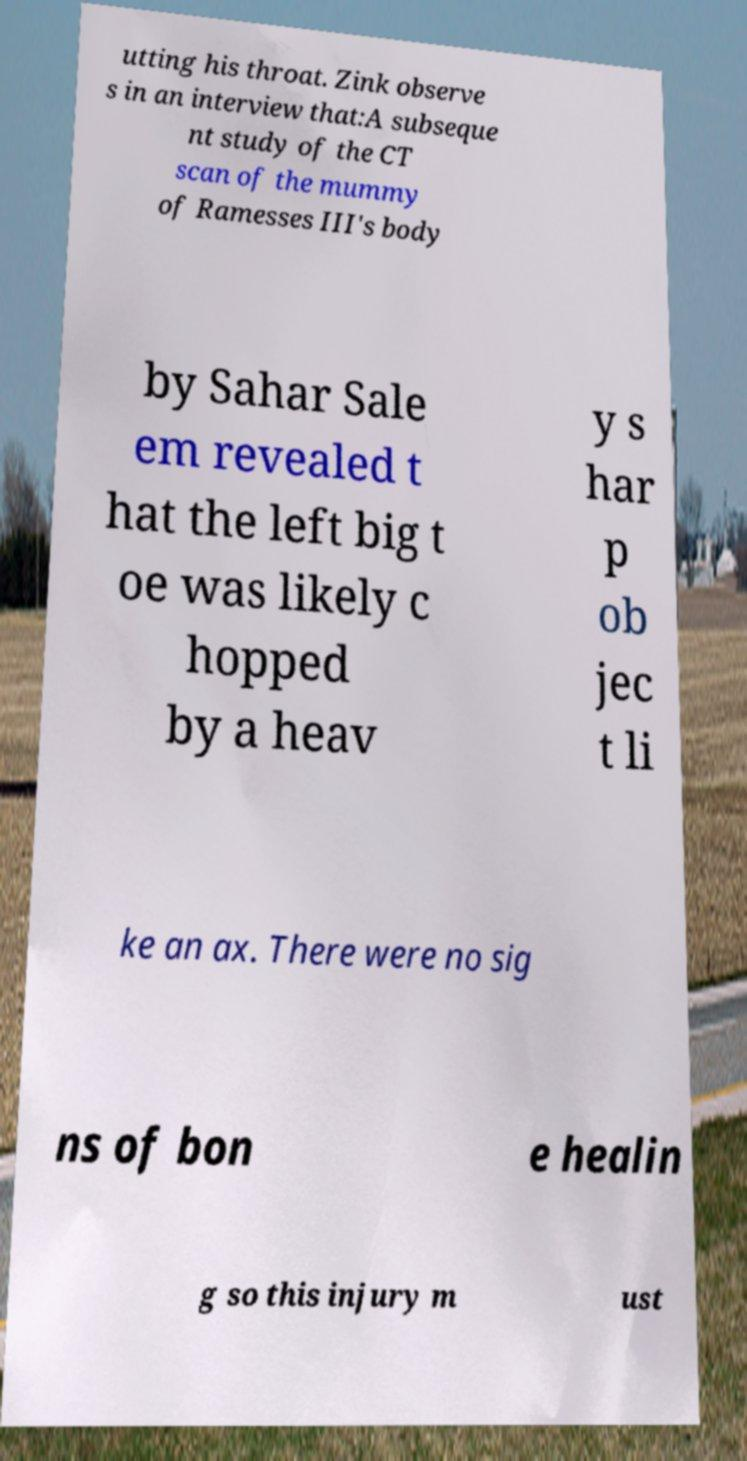Can you accurately transcribe the text from the provided image for me? utting his throat. Zink observe s in an interview that:A subseque nt study of the CT scan of the mummy of Ramesses III's body by Sahar Sale em revealed t hat the left big t oe was likely c hopped by a heav y s har p ob jec t li ke an ax. There were no sig ns of bon e healin g so this injury m ust 